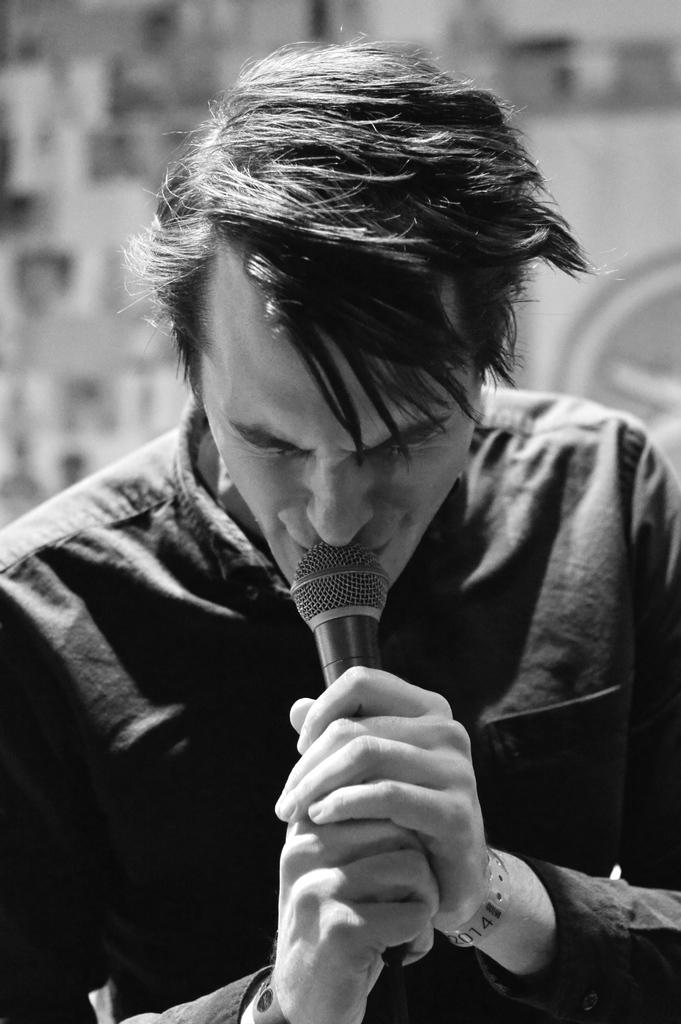What is the man in the image doing? The man is singing. What object is the man holding in his hand? The man is holding a mic in his hand. Can you describe the background of the image? The background of the image is blurry. What type of holiday is the man celebrating in the image? There is no indication of a holiday in the image; it simply shows a man singing while holding a mic. What type of drum is the man playing in the image? There is no drum present in the image. 